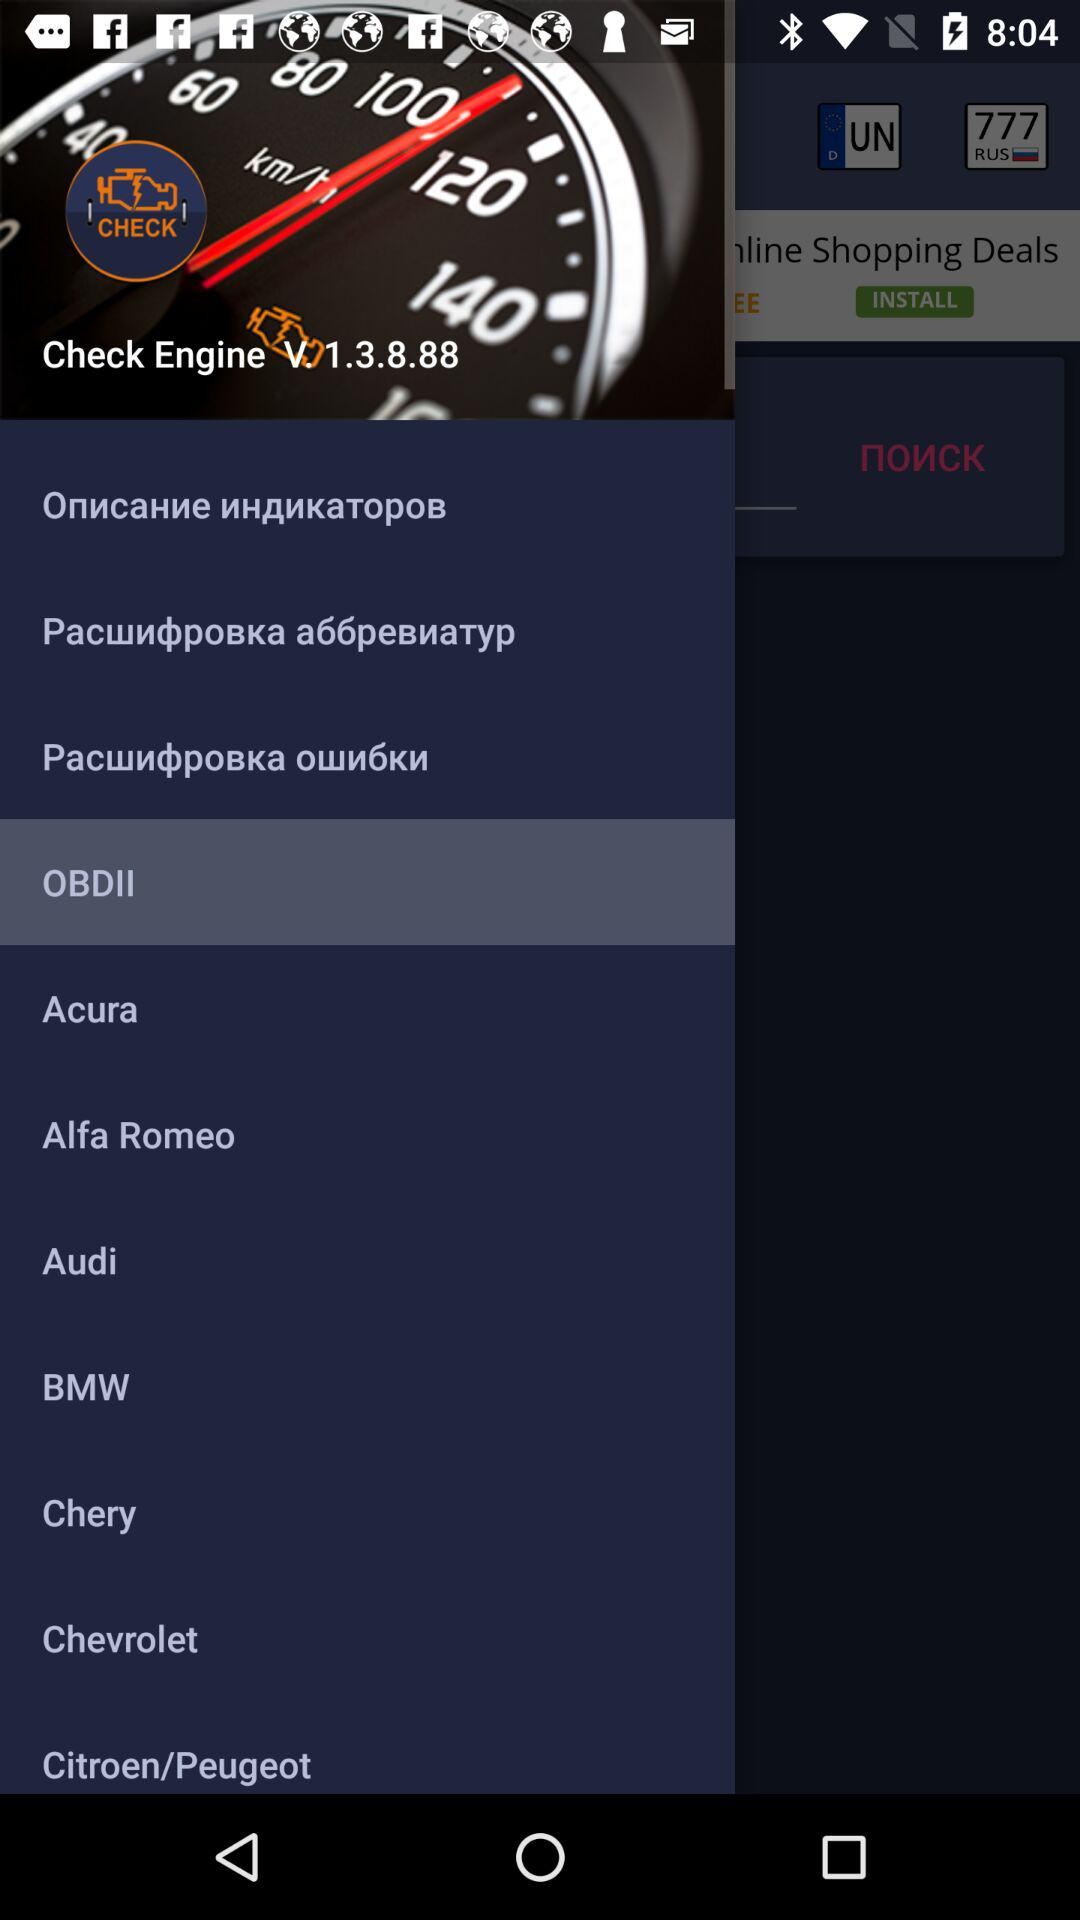What is the version of check engine? The version is V. 1.3.8.88. 